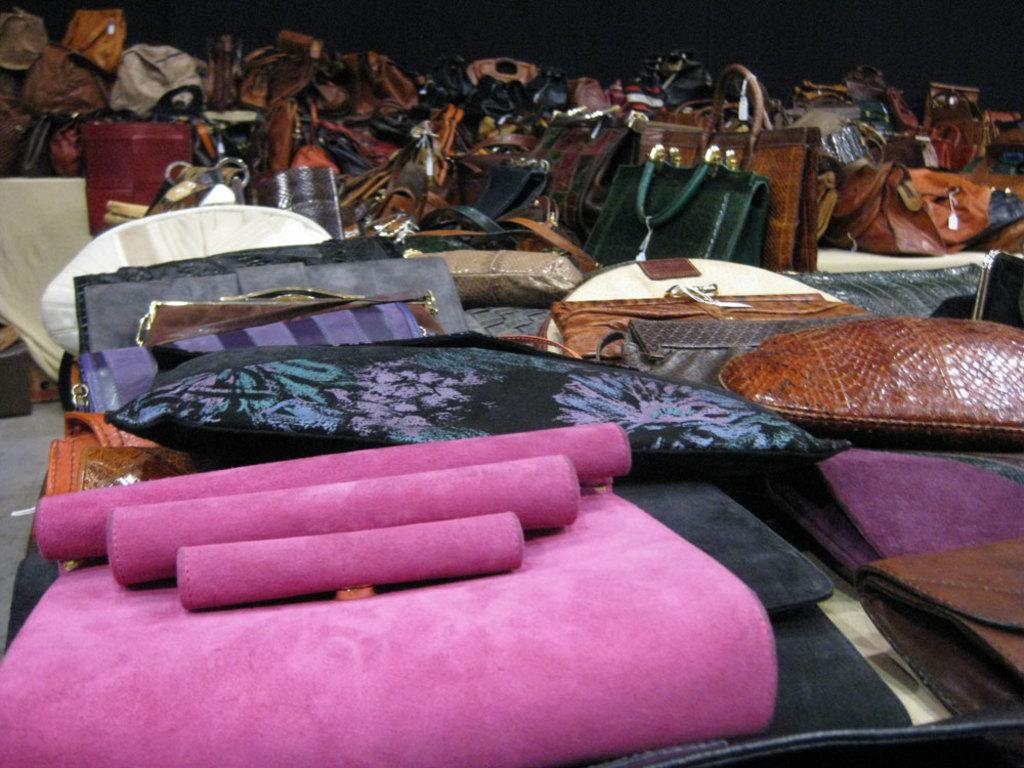What type of items are present in the image? There are many bags and purses in the image. Where are the bags and purses located? The bags and purses are kept in a room. What can be seen at the bottom of the image? There is a floor visible at the bottom of the image. What type of plane is flying over the bags and purses in the image? There is no plane visible in the image; it only features bags and purses in a room. 